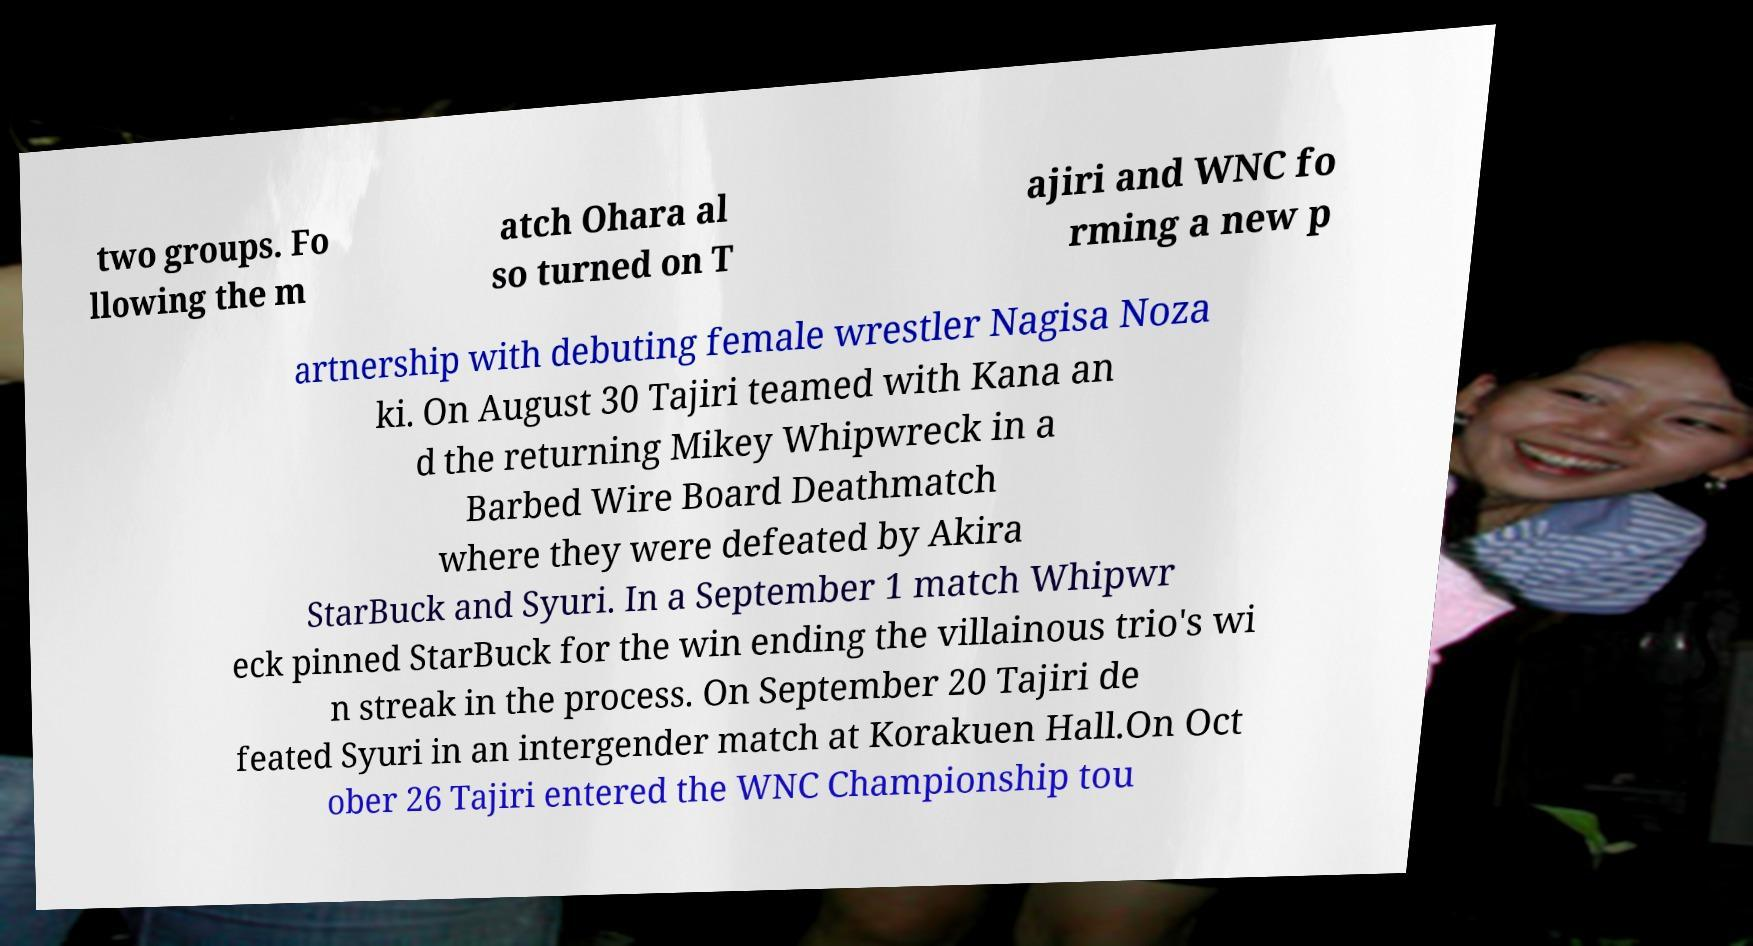There's text embedded in this image that I need extracted. Can you transcribe it verbatim? two groups. Fo llowing the m atch Ohara al so turned on T ajiri and WNC fo rming a new p artnership with debuting female wrestler Nagisa Noza ki. On August 30 Tajiri teamed with Kana an d the returning Mikey Whipwreck in a Barbed Wire Board Deathmatch where they were defeated by Akira StarBuck and Syuri. In a September 1 match Whipwr eck pinned StarBuck for the win ending the villainous trio's wi n streak in the process. On September 20 Tajiri de feated Syuri in an intergender match at Korakuen Hall.On Oct ober 26 Tajiri entered the WNC Championship tou 